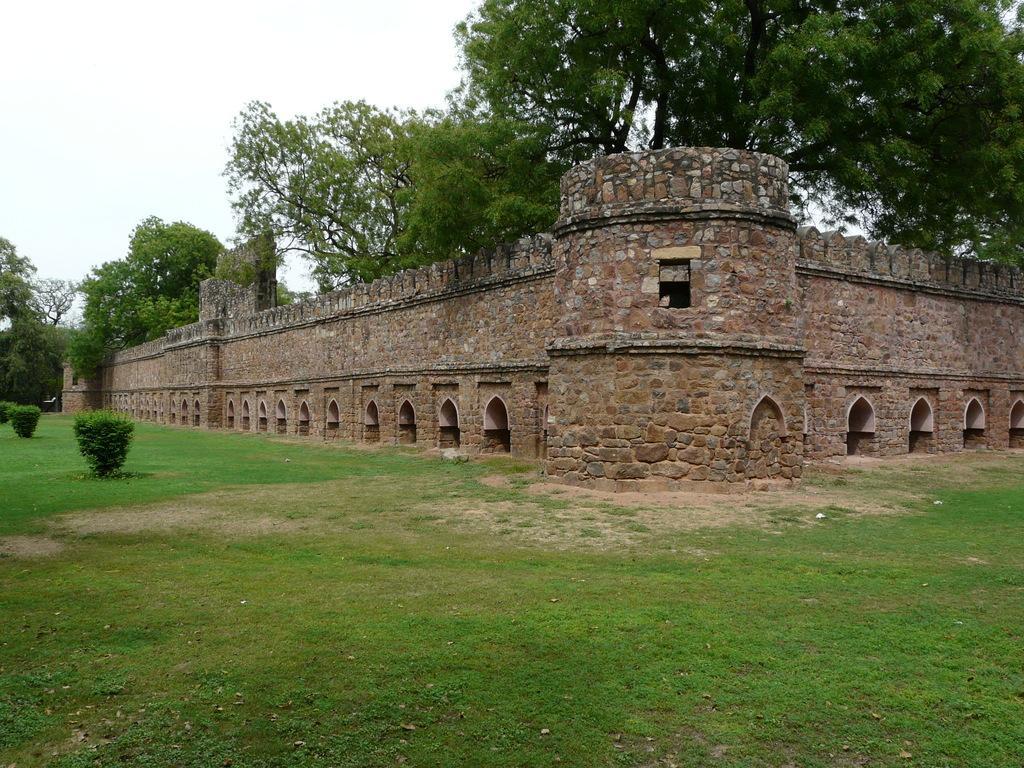How would you summarize this image in a sentence or two? In this image we can see grass, plants, wall, and trees. In the background there is sky. 